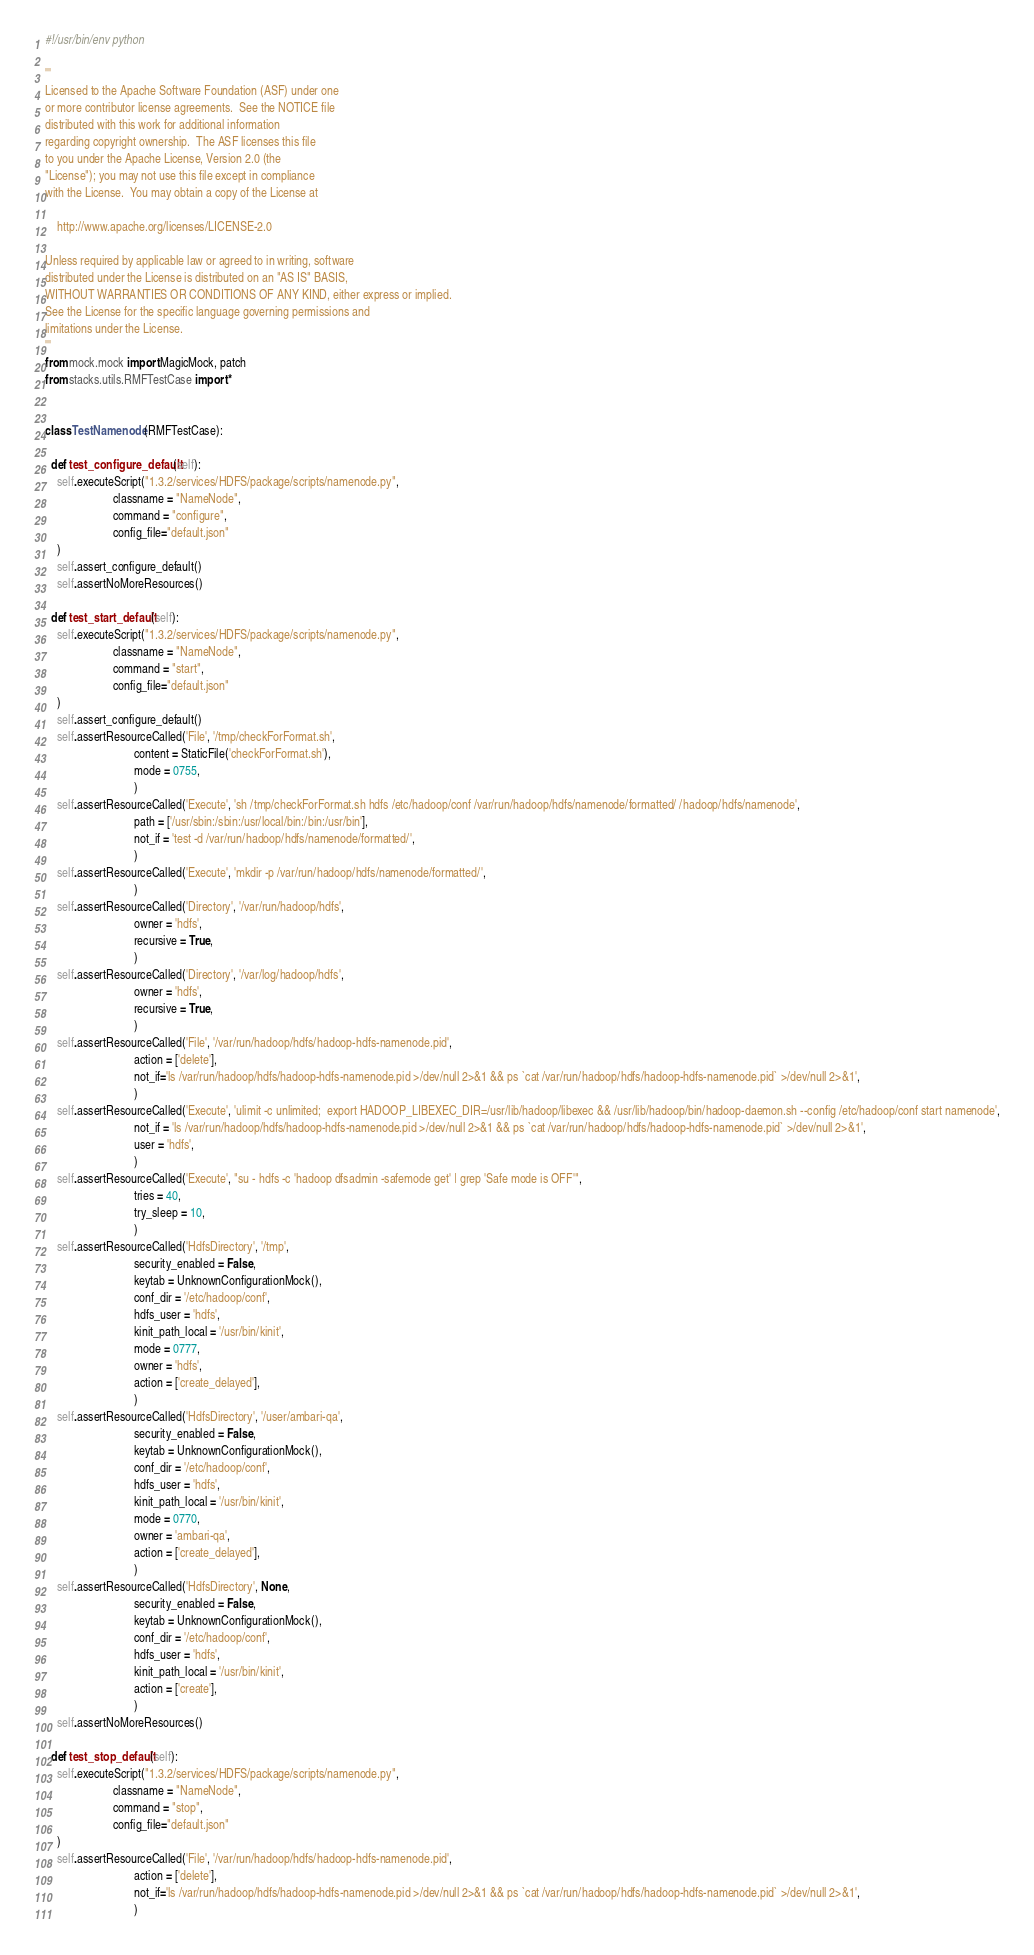Convert code to text. <code><loc_0><loc_0><loc_500><loc_500><_Python_>#!/usr/bin/env python

'''
Licensed to the Apache Software Foundation (ASF) under one
or more contributor license agreements.  See the NOTICE file
distributed with this work for additional information
regarding copyright ownership.  The ASF licenses this file
to you under the Apache License, Version 2.0 (the
"License"); you may not use this file except in compliance
with the License.  You may obtain a copy of the License at

    http://www.apache.org/licenses/LICENSE-2.0

Unless required by applicable law or agreed to in writing, software
distributed under the License is distributed on an "AS IS" BASIS,
WITHOUT WARRANTIES OR CONDITIONS OF ANY KIND, either express or implied.
See the License for the specific language governing permissions and
limitations under the License.
'''
from mock.mock import MagicMock, patch
from stacks.utils.RMFTestCase import *


class TestNamenode(RMFTestCase):

  def test_configure_default(self):
    self.executeScript("1.3.2/services/HDFS/package/scripts/namenode.py",
                       classname = "NameNode",
                       command = "configure",
                       config_file="default.json"
    )
    self.assert_configure_default()
    self.assertNoMoreResources()

  def test_start_default(self):
    self.executeScript("1.3.2/services/HDFS/package/scripts/namenode.py",
                       classname = "NameNode",
                       command = "start",
                       config_file="default.json"
    )
    self.assert_configure_default()
    self.assertResourceCalled('File', '/tmp/checkForFormat.sh',
                              content = StaticFile('checkForFormat.sh'),
                              mode = 0755,
                              )
    self.assertResourceCalled('Execute', 'sh /tmp/checkForFormat.sh hdfs /etc/hadoop/conf /var/run/hadoop/hdfs/namenode/formatted/ /hadoop/hdfs/namenode',
                              path = ['/usr/sbin:/sbin:/usr/local/bin:/bin:/usr/bin'],
                              not_if = 'test -d /var/run/hadoop/hdfs/namenode/formatted/',
                              )
    self.assertResourceCalled('Execute', 'mkdir -p /var/run/hadoop/hdfs/namenode/formatted/',
                              )
    self.assertResourceCalled('Directory', '/var/run/hadoop/hdfs',
                              owner = 'hdfs',
                              recursive = True,
                              )
    self.assertResourceCalled('Directory', '/var/log/hadoop/hdfs',
                              owner = 'hdfs',
                              recursive = True,
                              )
    self.assertResourceCalled('File', '/var/run/hadoop/hdfs/hadoop-hdfs-namenode.pid',
                              action = ['delete'],
                              not_if='ls /var/run/hadoop/hdfs/hadoop-hdfs-namenode.pid >/dev/null 2>&1 && ps `cat /var/run/hadoop/hdfs/hadoop-hdfs-namenode.pid` >/dev/null 2>&1',
                              )
    self.assertResourceCalled('Execute', 'ulimit -c unlimited;  export HADOOP_LIBEXEC_DIR=/usr/lib/hadoop/libexec && /usr/lib/hadoop/bin/hadoop-daemon.sh --config /etc/hadoop/conf start namenode',
                              not_if = 'ls /var/run/hadoop/hdfs/hadoop-hdfs-namenode.pid >/dev/null 2>&1 && ps `cat /var/run/hadoop/hdfs/hadoop-hdfs-namenode.pid` >/dev/null 2>&1',
                              user = 'hdfs',
                              )
    self.assertResourceCalled('Execute', "su - hdfs -c 'hadoop dfsadmin -safemode get' | grep 'Safe mode is OFF'",
                              tries = 40,
                              try_sleep = 10,
                              )
    self.assertResourceCalled('HdfsDirectory', '/tmp',
                              security_enabled = False,
                              keytab = UnknownConfigurationMock(),
                              conf_dir = '/etc/hadoop/conf',
                              hdfs_user = 'hdfs',
                              kinit_path_local = '/usr/bin/kinit',
                              mode = 0777,
                              owner = 'hdfs',
                              action = ['create_delayed'],
                              )
    self.assertResourceCalled('HdfsDirectory', '/user/ambari-qa',
                              security_enabled = False,
                              keytab = UnknownConfigurationMock(),
                              conf_dir = '/etc/hadoop/conf',
                              hdfs_user = 'hdfs',
                              kinit_path_local = '/usr/bin/kinit',
                              mode = 0770,
                              owner = 'ambari-qa',
                              action = ['create_delayed'],
                              )
    self.assertResourceCalled('HdfsDirectory', None,
                              security_enabled = False,
                              keytab = UnknownConfigurationMock(),
                              conf_dir = '/etc/hadoop/conf',
                              hdfs_user = 'hdfs',
                              kinit_path_local = '/usr/bin/kinit',
                              action = ['create'],
                              )
    self.assertNoMoreResources()

  def test_stop_default(self):
    self.executeScript("1.3.2/services/HDFS/package/scripts/namenode.py",
                       classname = "NameNode",
                       command = "stop",
                       config_file="default.json"
    )
    self.assertResourceCalled('File', '/var/run/hadoop/hdfs/hadoop-hdfs-namenode.pid',
                              action = ['delete'],
                              not_if='ls /var/run/hadoop/hdfs/hadoop-hdfs-namenode.pid >/dev/null 2>&1 && ps `cat /var/run/hadoop/hdfs/hadoop-hdfs-namenode.pid` >/dev/null 2>&1',
                              )</code> 